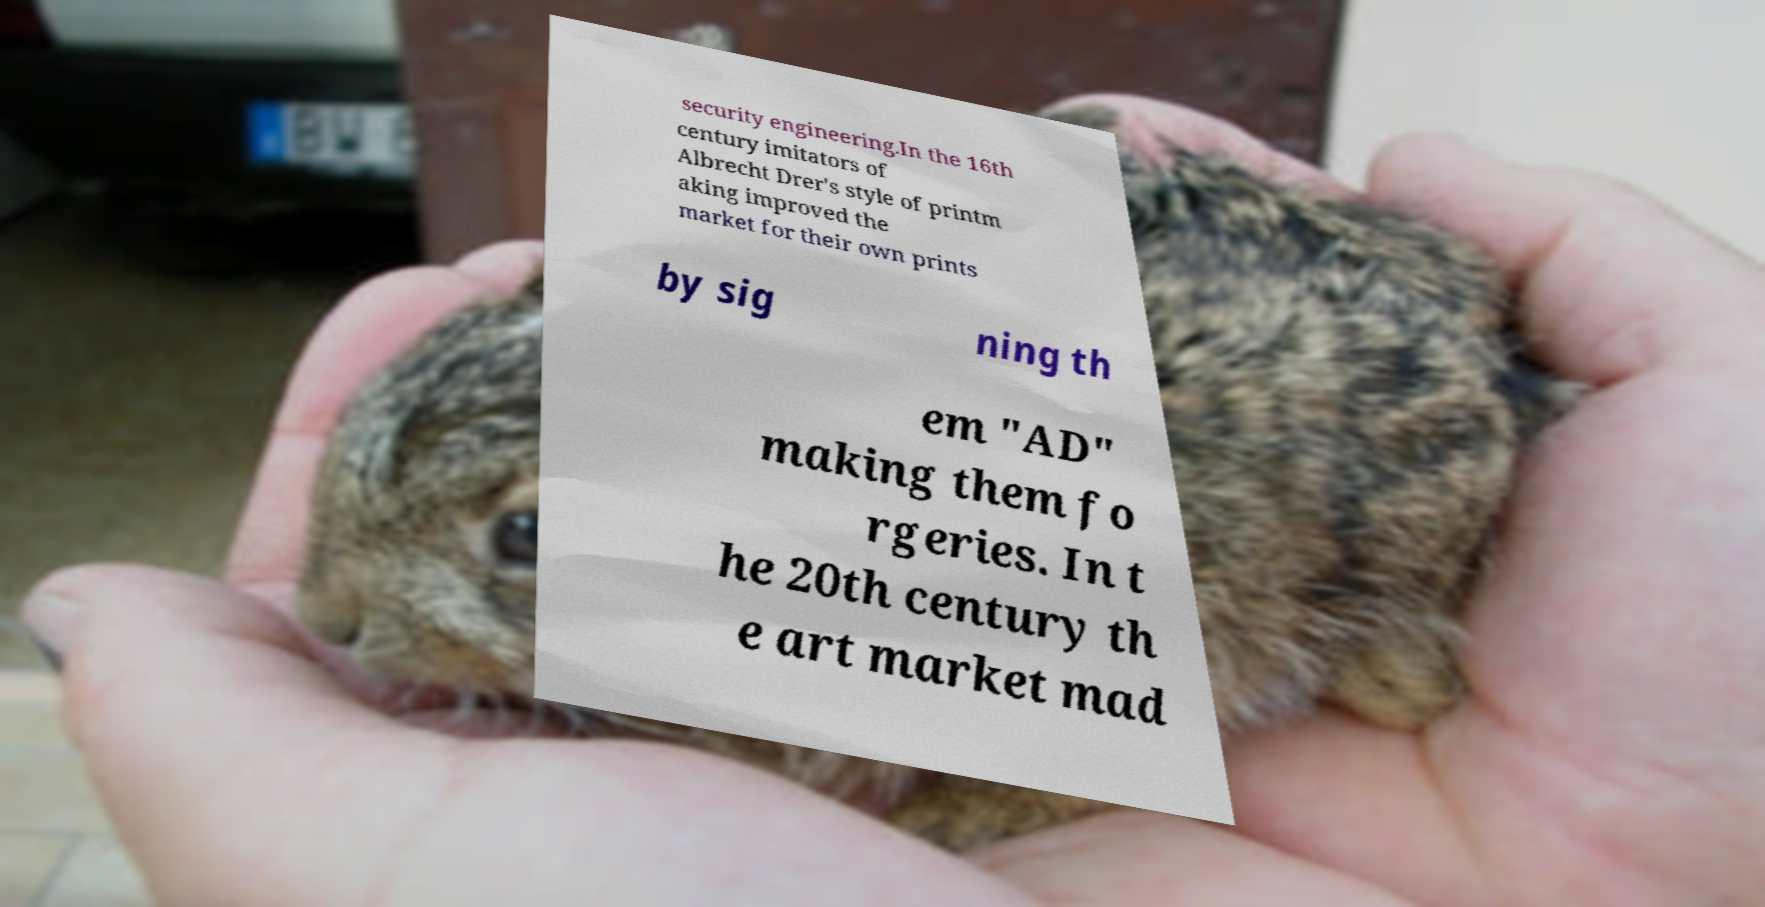Could you assist in decoding the text presented in this image and type it out clearly? security engineering.In the 16th century imitators of Albrecht Drer's style of printm aking improved the market for their own prints by sig ning th em "AD" making them fo rgeries. In t he 20th century th e art market mad 